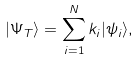<formula> <loc_0><loc_0><loc_500><loc_500>| \Psi _ { T } \rangle = \sum _ { i = 1 } ^ { N } k _ { i } | \psi _ { i } \rangle ,</formula> 